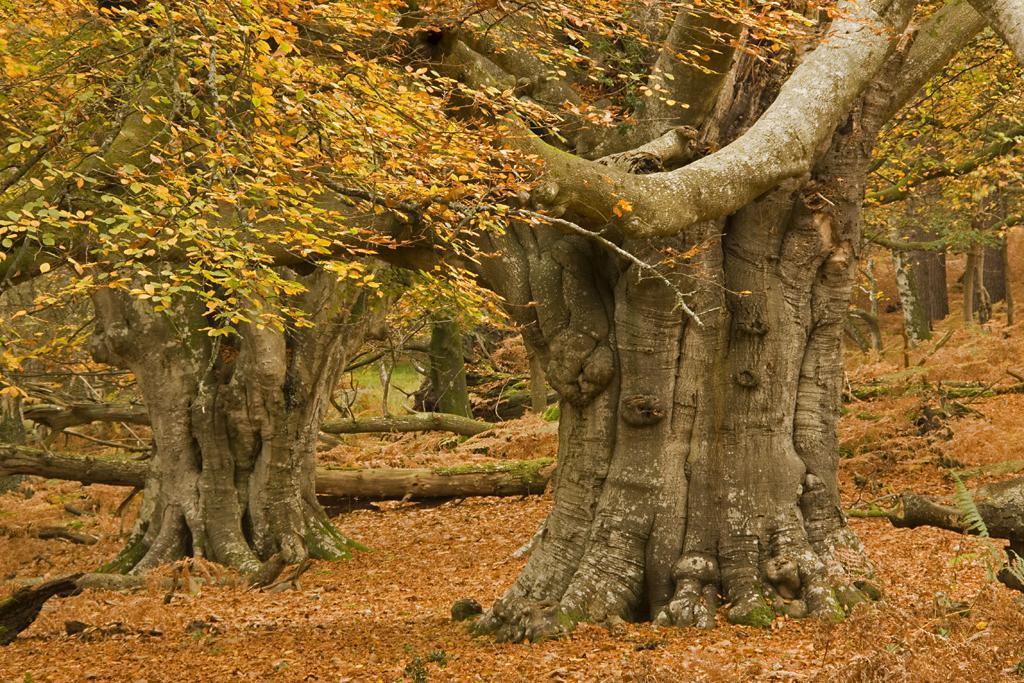Describe this image in one or two sentences. This place is looking like a forest. In this image I can see many trees and dry leaves on the ground and also there are few trunks. 